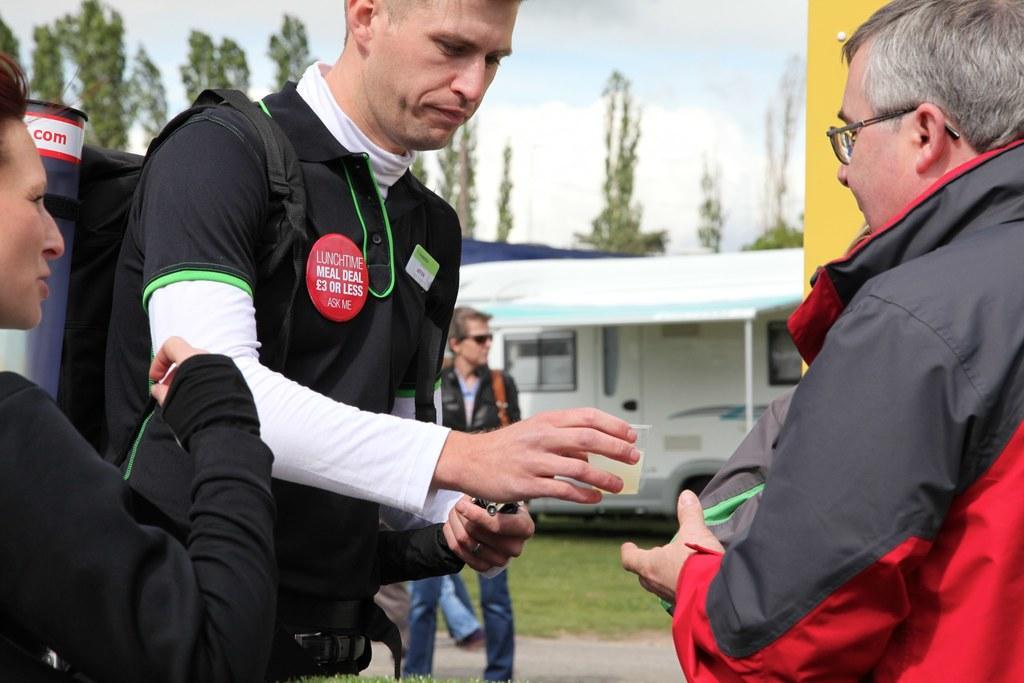Could you give a brief overview of what you see in this image? In this picture there a man wearing black color t-shirt giving a teacup to the front person wearing black and red jacket. In the background we can see some trees. 